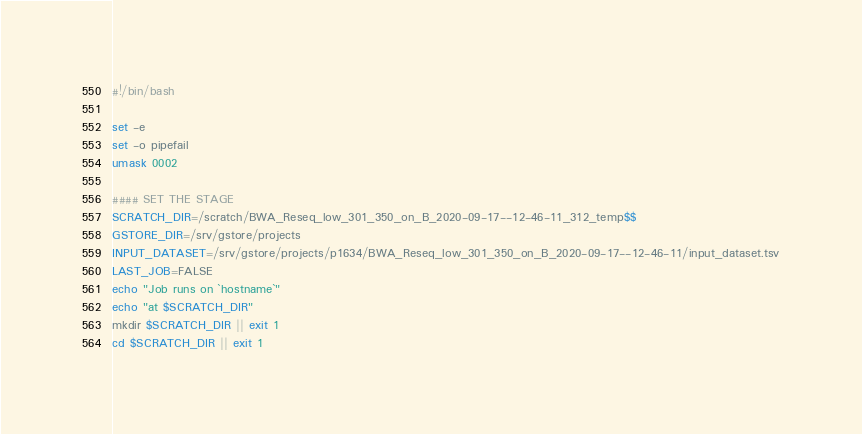<code> <loc_0><loc_0><loc_500><loc_500><_Bash_>#!/bin/bash

set -e
set -o pipefail
umask 0002

#### SET THE STAGE
SCRATCH_DIR=/scratch/BWA_Reseq_low_301_350_on_B_2020-09-17--12-46-11_312_temp$$
GSTORE_DIR=/srv/gstore/projects
INPUT_DATASET=/srv/gstore/projects/p1634/BWA_Reseq_low_301_350_on_B_2020-09-17--12-46-11/input_dataset.tsv
LAST_JOB=FALSE
echo "Job runs on `hostname`"
echo "at $SCRATCH_DIR"
mkdir $SCRATCH_DIR || exit 1
cd $SCRATCH_DIR || exit 1</code> 